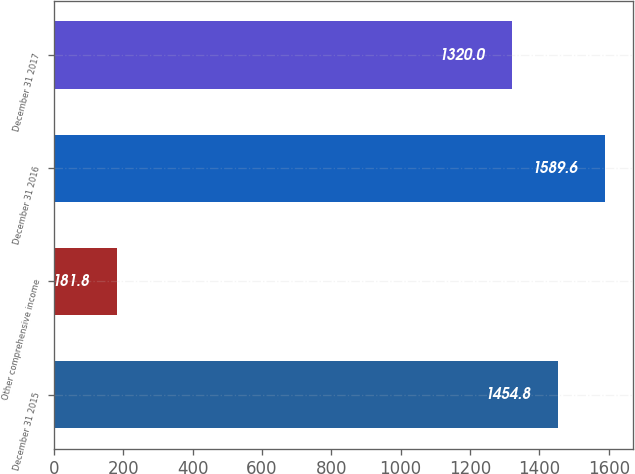Convert chart. <chart><loc_0><loc_0><loc_500><loc_500><bar_chart><fcel>December 31 2015<fcel>Other comprehensive income<fcel>December 31 2016<fcel>December 31 2017<nl><fcel>1454.8<fcel>181.8<fcel>1589.6<fcel>1320<nl></chart> 